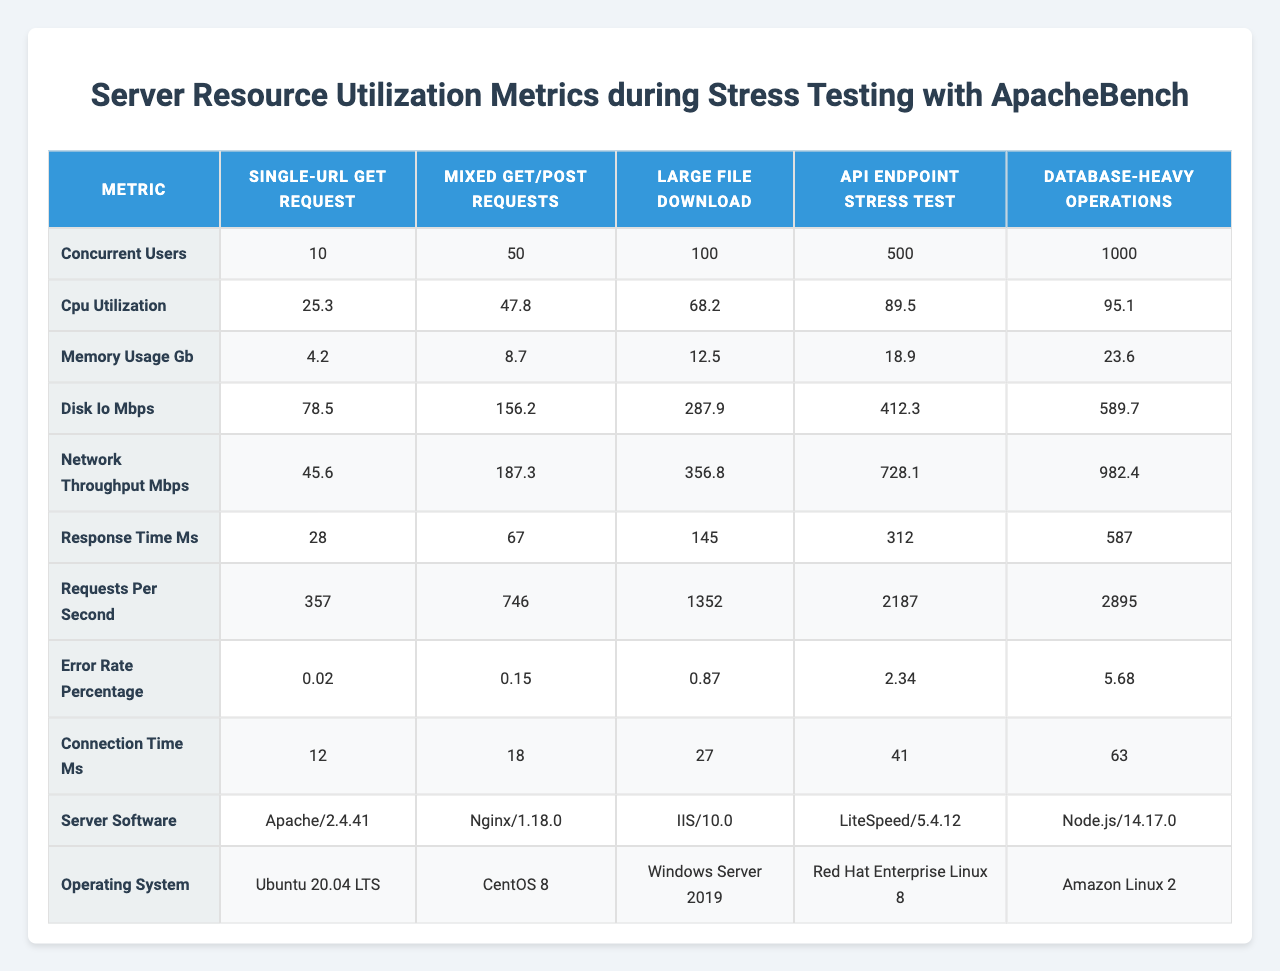What is the CPU utilization for 500 concurrent users? The CPU utilization for 500 concurrent users can be found in the corresponding row under the "CPU Utilization" metric and "500" column, which shows a value of 89.5.
Answer: 89.5 What is the error rate percentage for the "Large File Download" test scenario? The error rate percentage for the "Large File Download" test scenario can be found in the "Error Rate Percentage" row, and the column corresponding to "Large File Download" shows a value of 0.87.
Answer: 0.87 What is the maximum memory usage in GB across all test scenarios? To find the maximum memory usage, we look at the "Memory Usage (GB)" row. The values are 4.2, 8.7, 12.5, 18.9, and 23.6. The highest value is 23.6.
Answer: 23.6 Is the server software for "Database-heavy Operations" Apache? The server software for "Database-heavy Operations" can be found in the row of "Server Software," and the corresponding value is "Node.js/14.17.0." Since it is not Apache, the answer is no.
Answer: No What is the average response time across all test scenarios? We identify the response times for all test scenarios: 28, 67, 145, 312, and 587. We sum these values, obtaining 28 + 67 + 145 + 312 + 587 = 1139, and dividing by 5 gives an average of 1139 / 5 = 227.8.
Answer: 227.8 How does the network throughput change from 100 to 1000 concurrent users? We observe the network throughput for 100 users is 356.8 Mbps and for 1000 users is 982.4 Mbps. The change is calculated as 982.4 - 356.8 = 625.6 Mbps.
Answer: 625.6 Mbps What is the percentage increase in requests per second from 50 to 100 concurrent users? The requests per second for 50 users is 746 and for 100 users it is 1352. The increase is calculated as (1352 - 746) / 746 * 100 = 81.0%.
Answer: 81.0% Which test scenario has the highest connection time in ms? In the "Connection Time (ms)" row, comparison shows the values are 12, 18, 27, 41, and 63 ms. The highest value is 63 ms, corresponding to "Database-heavy Operations."
Answer: Database-heavy Operations What is the ratio of disk I/O to CPU utilization for 100 concurrent users? At 100 concurrent users, the disk I/O value is 287.9 Mbps and CPU utilization is 68.2. The ratio is calculated as 287.9 / 68.2 ≈ 4.22.
Answer: 4.22 Did memory usage exceed 20 GB for any of the test scenarios? The maximum memory usage value across all scenarios is 23.6 GB, which exceeds 20 GB. Thus, the answer is yes.
Answer: Yes What is the trend of response time as concurrent users increase from 10 to 1000? The response times are 28 ms (10 users), 67 ms (50 users), 145 ms (100 users), 312 ms (500 users), and 587 ms (1000 users). As users increase, the response time is rising significantly, indicating a negative trend in performance.
Answer: Increasing trend 